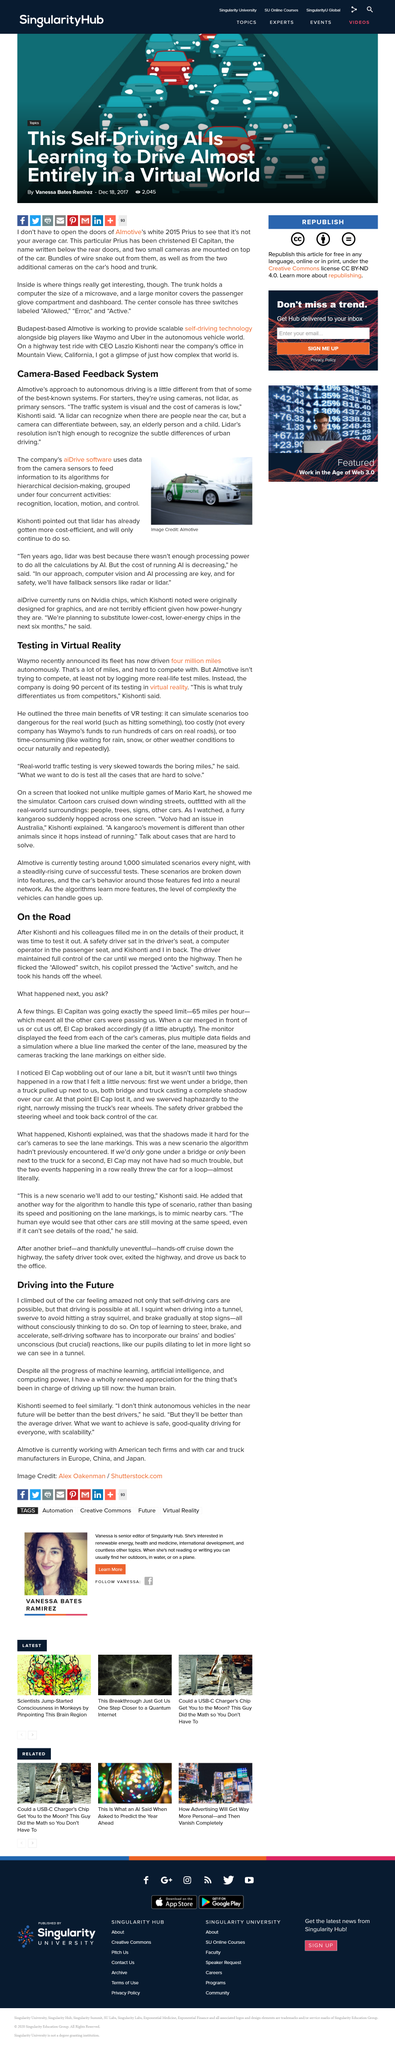Highlight a few significant elements in this photo. Self-driving software must incorporate the essential and unconscious reactions of the human brain and body, in order to operate safely and effectively in various driving scenarios. The lane was painted blue, with a center line of a different color. Almotive differentiates itself from competitors through its exclusive use of virtual reality in 90% of its testing processes. There were four passengers in the car. The external mounting locations of cameras on El Capitan are the top of the car, the hood, and the trunk. 